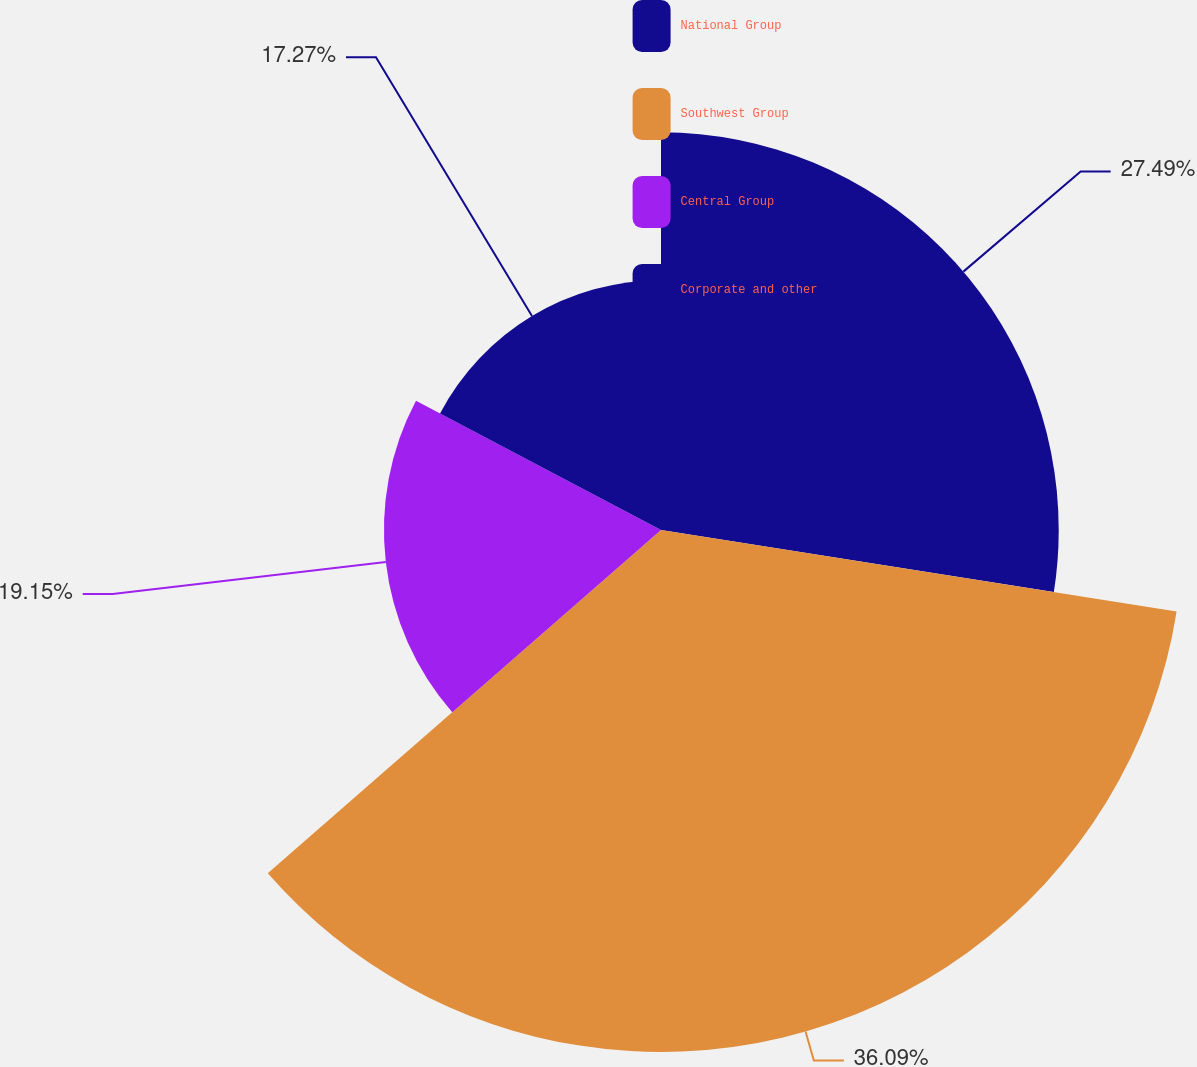Convert chart to OTSL. <chart><loc_0><loc_0><loc_500><loc_500><pie_chart><fcel>National Group<fcel>Southwest Group<fcel>Central Group<fcel>Corporate and other<nl><fcel>27.49%<fcel>36.08%<fcel>19.15%<fcel>17.27%<nl></chart> 